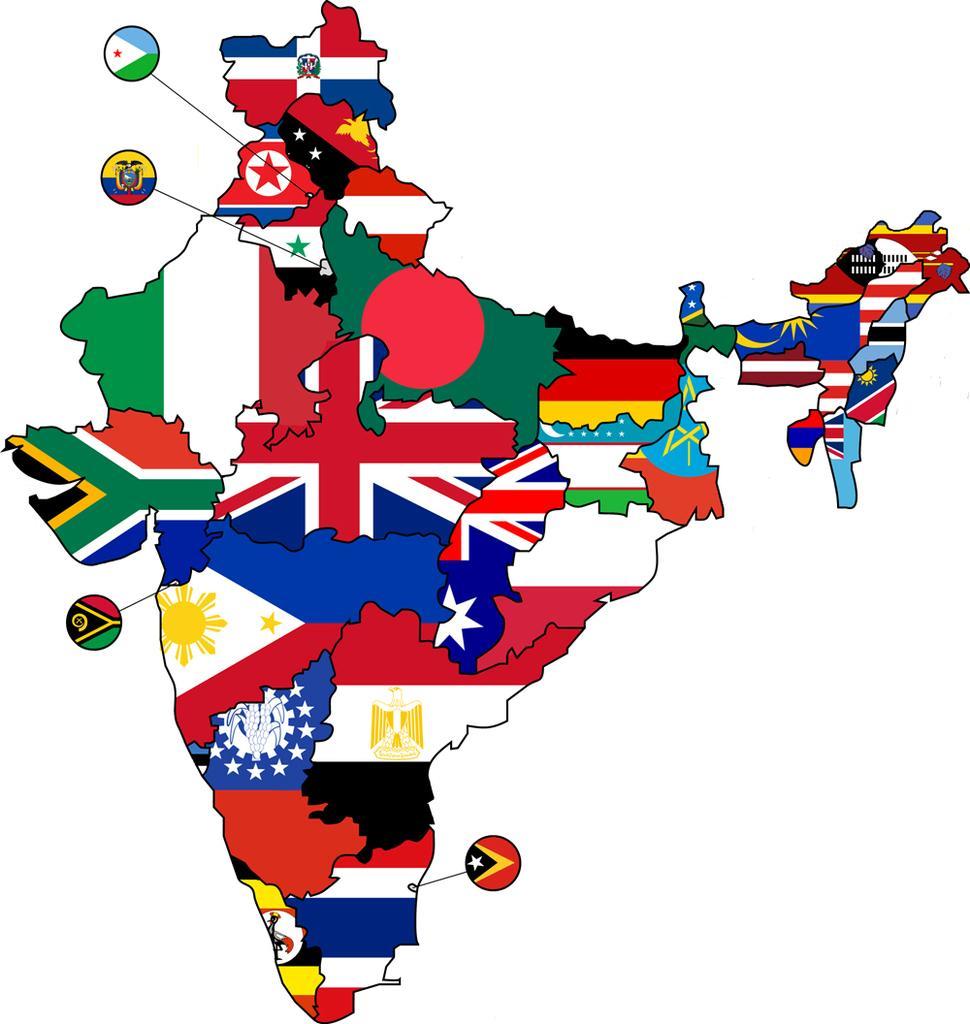Describe this image in one or two sentences. In this image we can see a map of India made with different flags of countries. In the background it is white. 